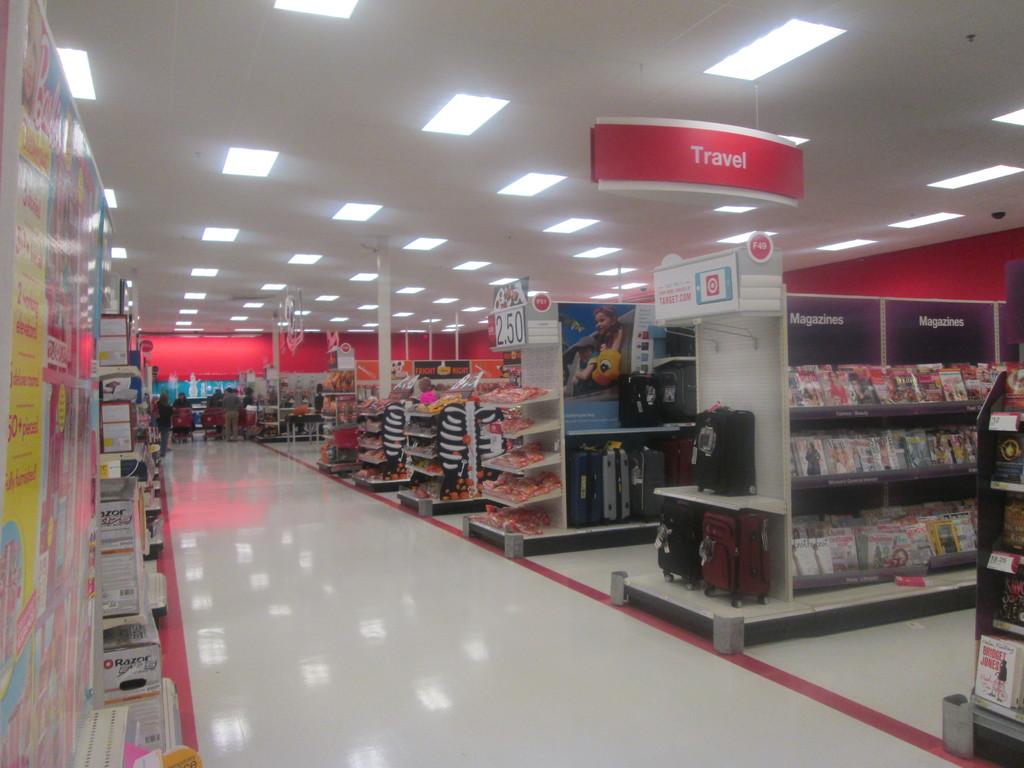What store is this?
Offer a very short reply. Answering does not require reading text in the image. What section is this a picture of?
Your response must be concise. Travel. 